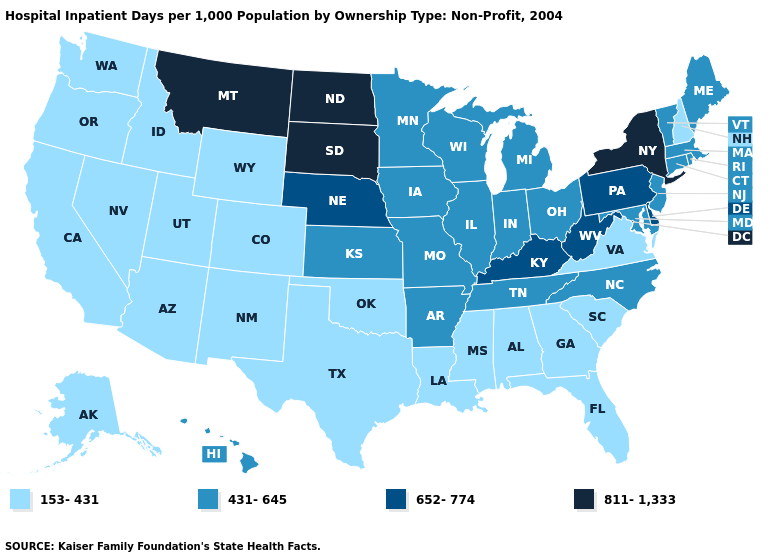Name the states that have a value in the range 652-774?
Answer briefly. Delaware, Kentucky, Nebraska, Pennsylvania, West Virginia. What is the highest value in states that border Kansas?
Keep it brief. 652-774. What is the highest value in the USA?
Write a very short answer. 811-1,333. Which states have the lowest value in the MidWest?
Be succinct. Illinois, Indiana, Iowa, Kansas, Michigan, Minnesota, Missouri, Ohio, Wisconsin. How many symbols are there in the legend?
Quick response, please. 4. Which states have the lowest value in the USA?
Short answer required. Alabama, Alaska, Arizona, California, Colorado, Florida, Georgia, Idaho, Louisiana, Mississippi, Nevada, New Hampshire, New Mexico, Oklahoma, Oregon, South Carolina, Texas, Utah, Virginia, Washington, Wyoming. Does New York have the highest value in the Northeast?
Answer briefly. Yes. What is the highest value in the USA?
Quick response, please. 811-1,333. Name the states that have a value in the range 652-774?
Quick response, please. Delaware, Kentucky, Nebraska, Pennsylvania, West Virginia. How many symbols are there in the legend?
Keep it brief. 4. Does Hawaii have a higher value than Virginia?
Quick response, please. Yes. Name the states that have a value in the range 811-1,333?
Answer briefly. Montana, New York, North Dakota, South Dakota. Name the states that have a value in the range 153-431?
Answer briefly. Alabama, Alaska, Arizona, California, Colorado, Florida, Georgia, Idaho, Louisiana, Mississippi, Nevada, New Hampshire, New Mexico, Oklahoma, Oregon, South Carolina, Texas, Utah, Virginia, Washington, Wyoming. Name the states that have a value in the range 811-1,333?
Short answer required. Montana, New York, North Dakota, South Dakota. 